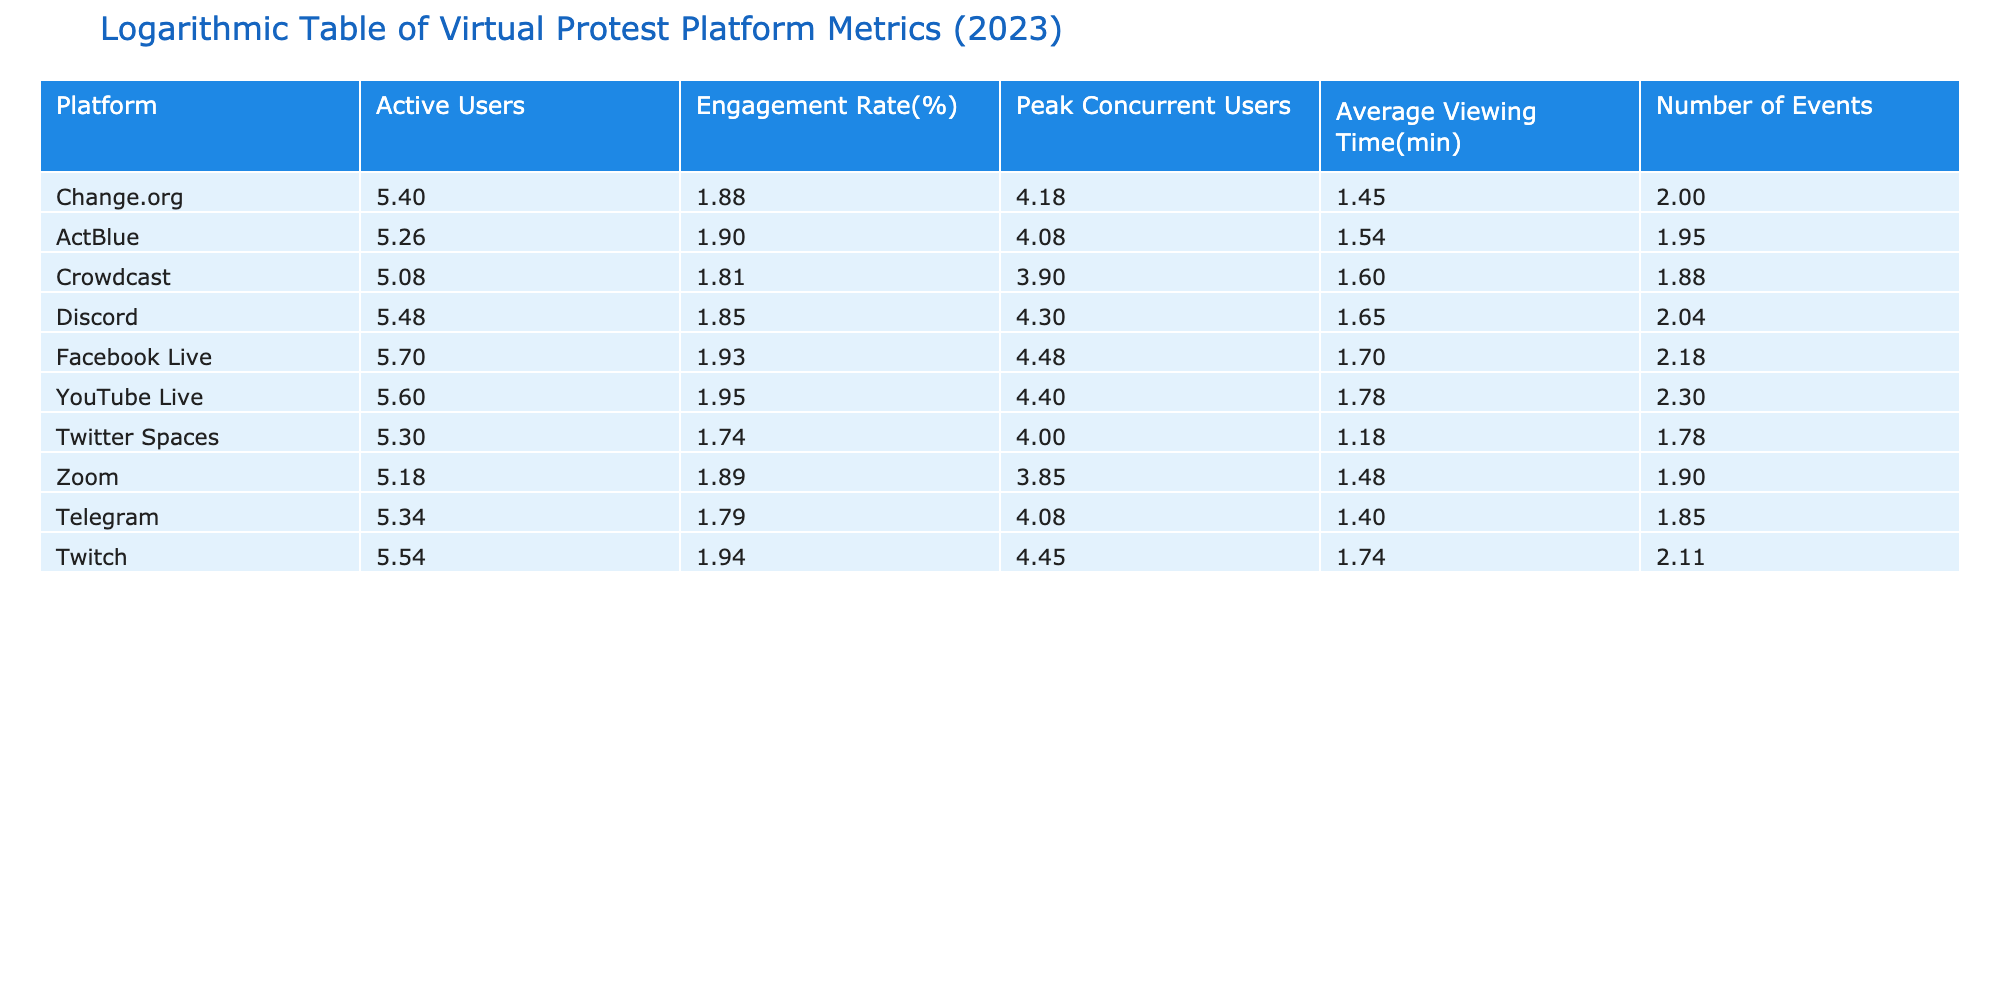What is the engagement rate for Twitch? The engagement rate for Twitch can be found directly in the table under the "Engagement Rate(%)" column. It shows a value of 88.
Answer: 88 How many active users does Facebook Live have? By looking at the "Active Users" column in the table, we can see that Facebook Live has 500,000 active users.
Answer: 500000 What is the average viewing time for platforms with an engagement rate higher than 75%? First, filter the platforms with an engagement rate higher than 75%, which includes ActBlue, Facebook Live, YouTube Live, Twitch. Then, sum their average viewing times: 35 (ActBlue) + 50 (Facebook Live) + 60 (YouTube Live) + 55 (Twitch) = 200 minutes. Next, knowing there are 4 platforms, calculate the average: 200/4 = 50 minutes.
Answer: 50 Does Discord have more active users than Crowdcast? Comparing the "Active Users" values in the table, Discord has 300,000 active users while Crowdcast has 120,000. Therefore, Discord has more active users.
Answer: Yes What is the difference in average viewing time between the platform with the highest and lowest viewing time? Identifying the highest average viewing time, which is 60 minutes for YouTube Live, and the lowest average viewing time of 15 minutes for Twitter Spaces. The difference is calculated as 60 - 15 = 45 minutes.
Answer: 45 What is the total number of events held across all platforms? To find the total number of events, sum up the "Number of Events" for each platform: 100 + 90 + 75 + 110 + 150 + 200 + 60 + 80 + 70 + 130 = 1,065 events.
Answer: 1065 Is there a platform that has more than 250,000 active users and an engagement rate of at least 80%? Checking the table, both Facebook Live (500,000 active users, 85%) and YouTube Live (400,000 active users, 90%) meet these criteria.
Answer: Yes What is the median engagement rate across all platforms? To find the median engagement rate, we first arrange the engagement rates in ascending order: 55, 62, 65, 70, 75, 78, 80, 85, 88, 90. Since there are 10 values, the median is the average of the 5th and 6th values: (75 + 78) / 2 = 76.5.
Answer: 76.5 